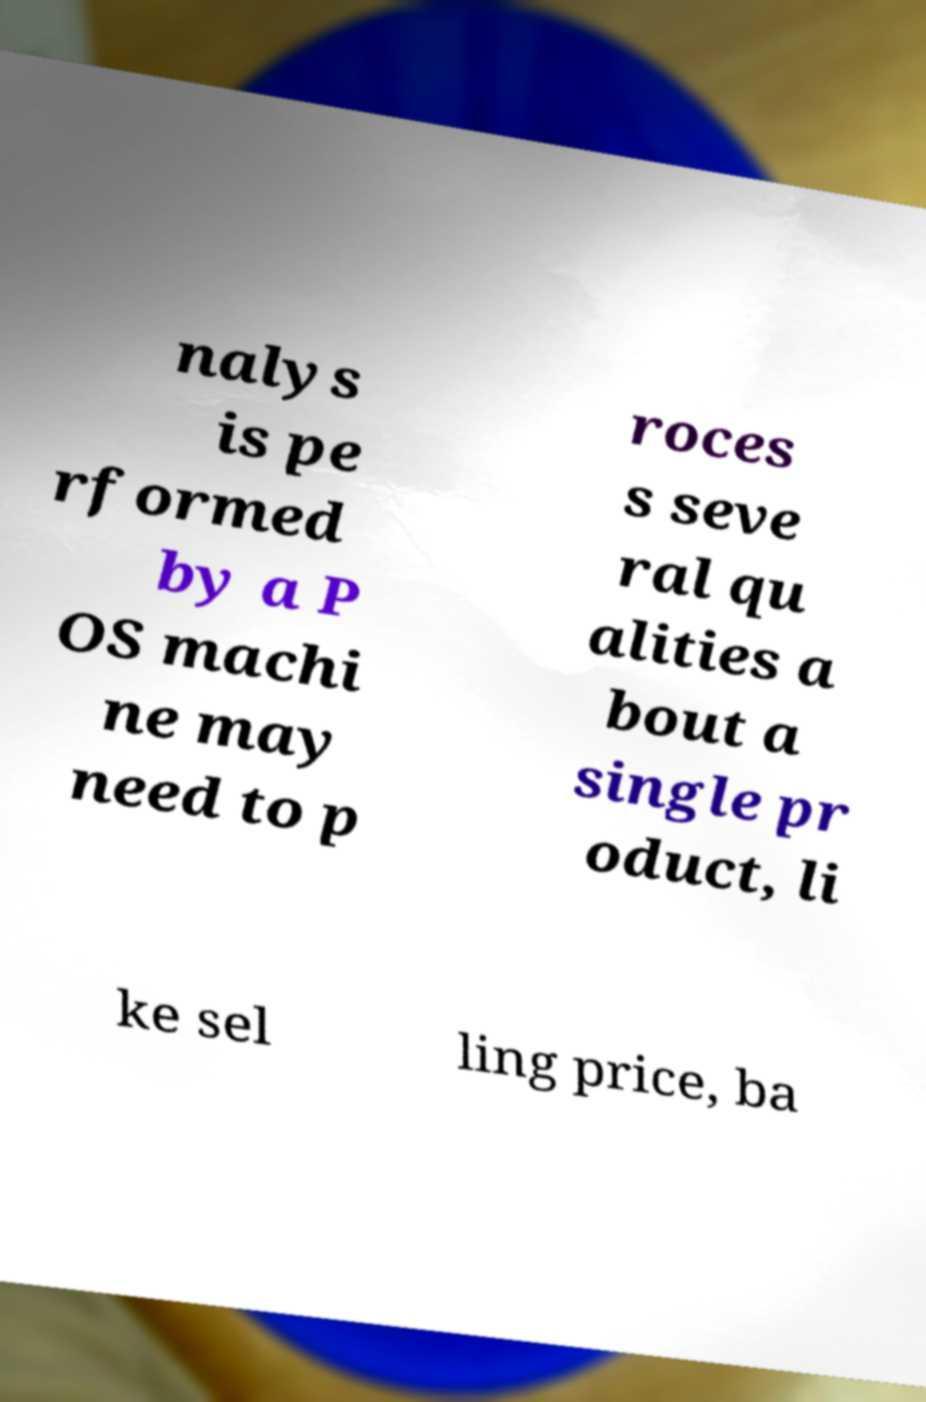Could you assist in decoding the text presented in this image and type it out clearly? nalys is pe rformed by a P OS machi ne may need to p roces s seve ral qu alities a bout a single pr oduct, li ke sel ling price, ba 